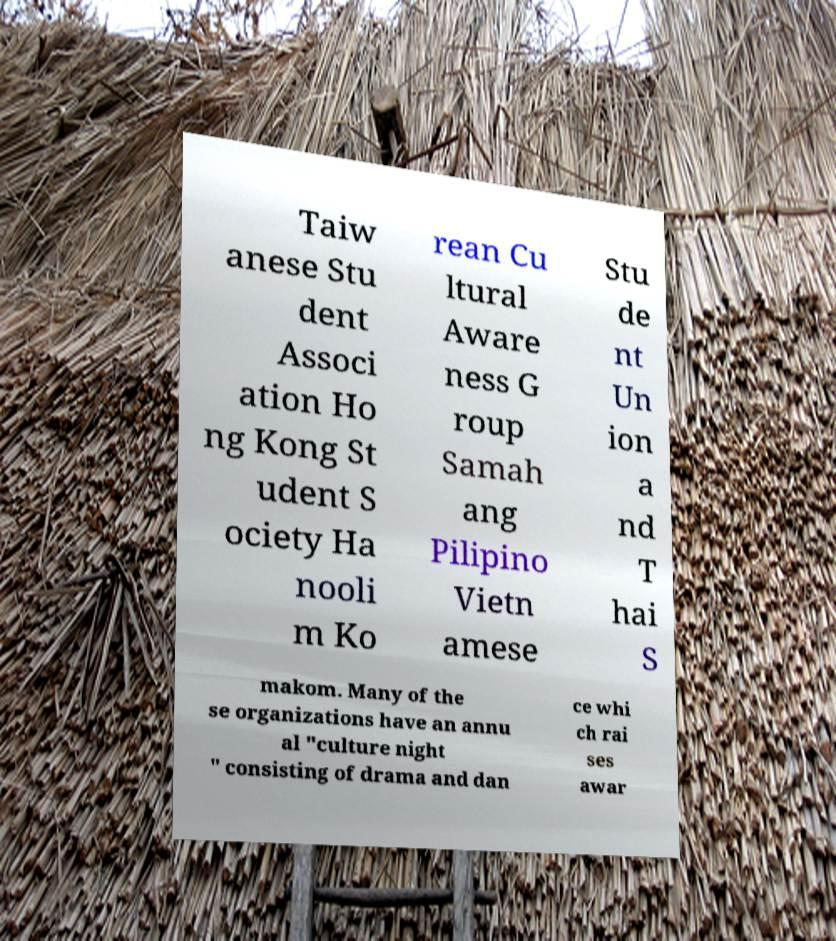Could you assist in decoding the text presented in this image and type it out clearly? Taiw anese Stu dent Associ ation Ho ng Kong St udent S ociety Ha nooli m Ko rean Cu ltural Aware ness G roup Samah ang Pilipino Vietn amese Stu de nt Un ion a nd T hai S makom. Many of the se organizations have an annu al "culture night " consisting of drama and dan ce whi ch rai ses awar 